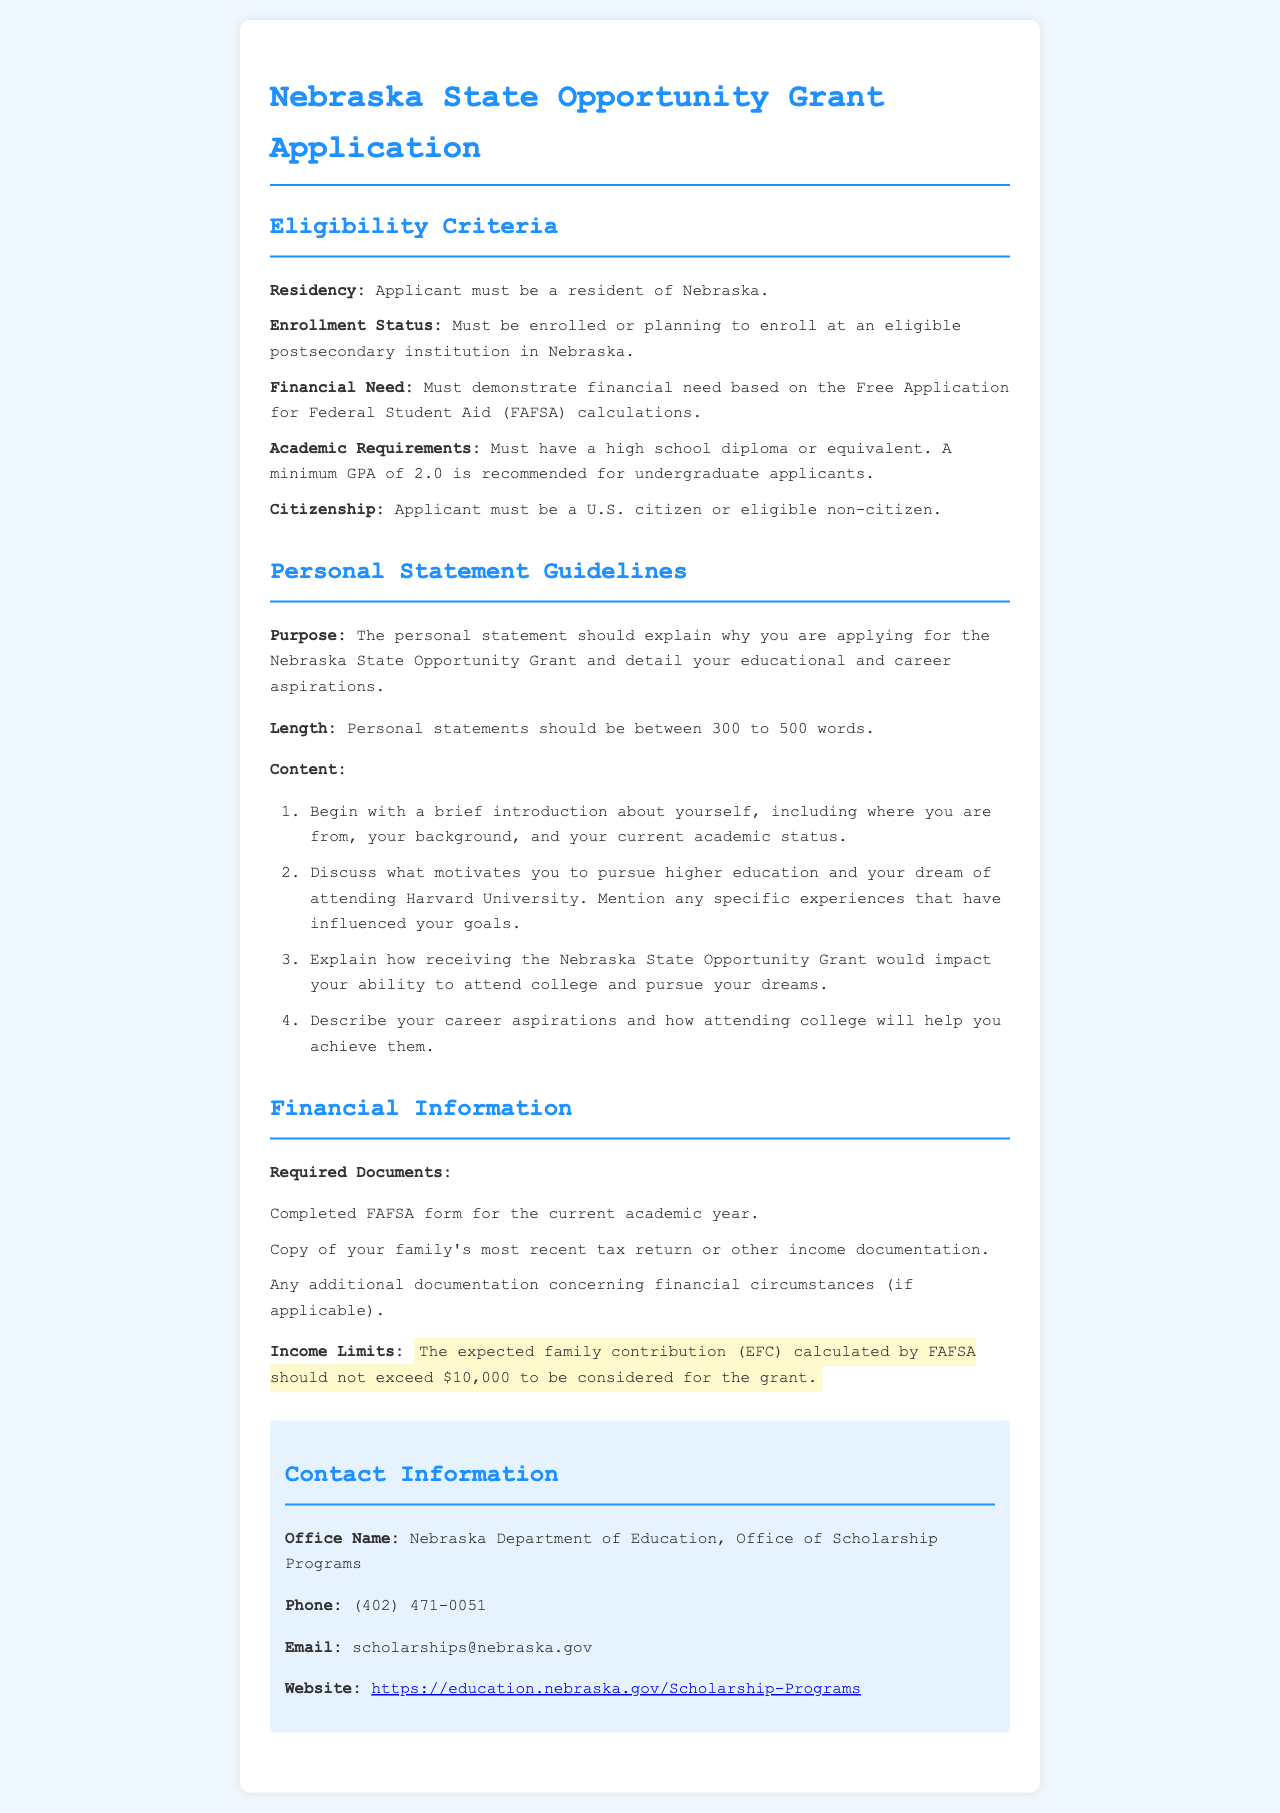What is the maximum recommended GPA for undergraduate applicants? The document states that a minimum GPA of 2.0 is recommended for undergraduate applicants.
Answer: 2.0 What is the expected family contribution limit to be considered for the grant? The document specifies that the expected family contribution (EFC) calculated by FAFSA should not exceed $10,000 to be considered for the grant.
Answer: $10,000 What is the length range for the personal statement? The document indicates that personal statements should be between 300 to 500 words.
Answer: 300 to 500 words Who should you contact for more information about the grant? The document identifies the Nebraska Department of Education, Office of Scholarship Programs as the office to contact for more information.
Answer: Nebraska Department of Education, Office of Scholarship Programs What type of paperwork is required to apply? The document lists required documents including the completed FAFSA form and a copy of the family's most recent tax return.
Answer: Completed FAFSA form, tax return copy What citizenship status must an applicant have? The document indicates that the applicant must be a U.S. citizen or eligible non-citizen.
Answer: U.S. citizen or eligible non-citizen What should the personal statement explain? The document states that the personal statement should explain why you are applying for the Nebraska State Opportunity Grant and detail your educational and career aspirations.
Answer: Why applying for the grant and aspirations What motivates you to pursue higher education? This is a part of the personal statement content, which asks for a discussion of motivations for pursuing higher education.
Answer: Motivations for pursuing higher education Which additional documentation might be needed if applicable? The document mentions any additional documentation concerning financial circumstances as potentially required.
Answer: Additional documentation concerning financial circumstances 